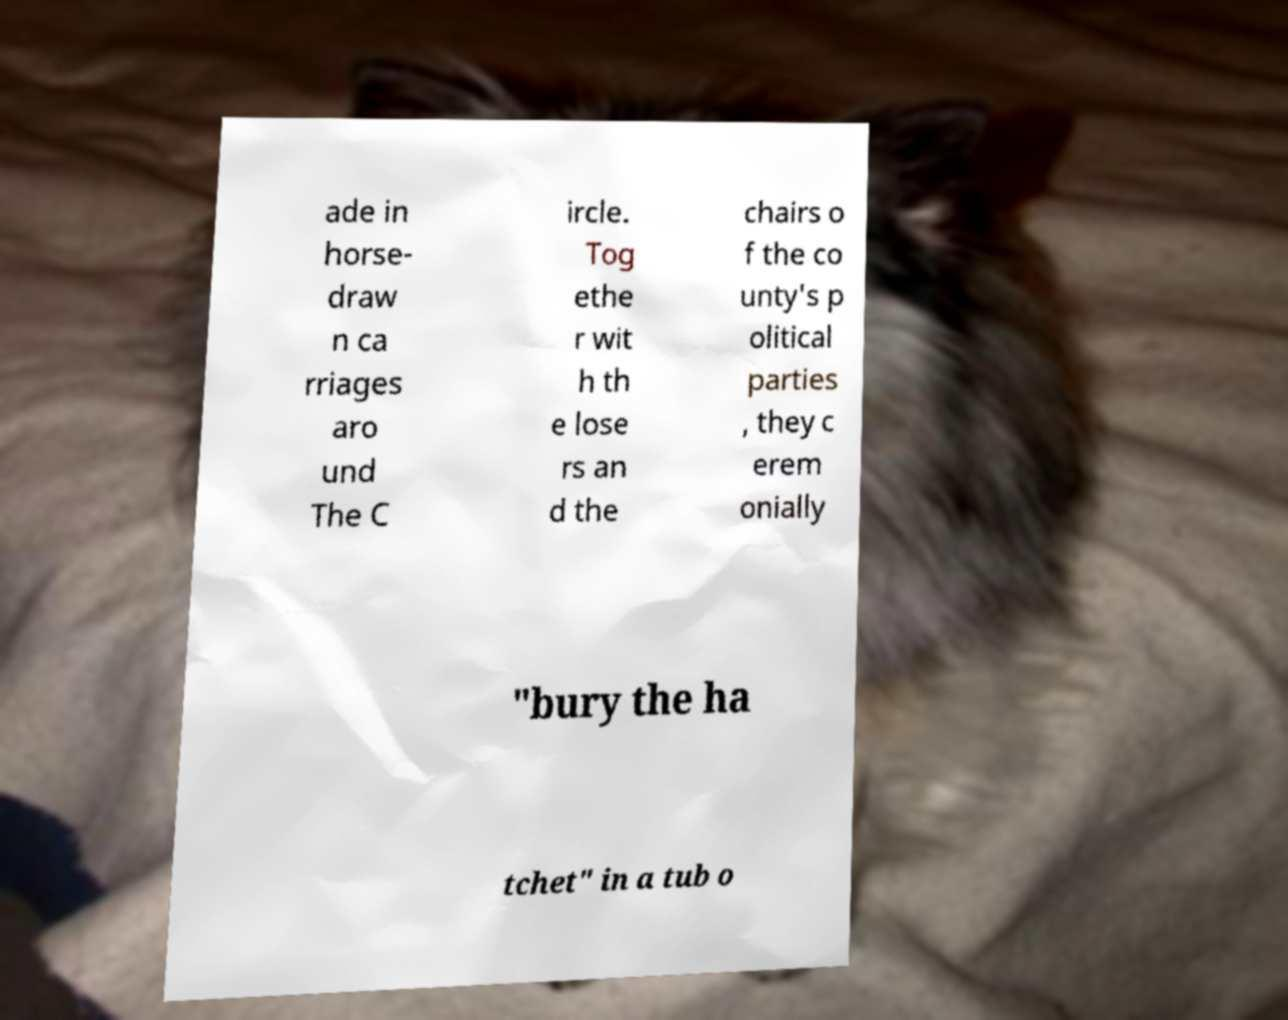I need the written content from this picture converted into text. Can you do that? ade in horse- draw n ca rriages aro und The C ircle. Tog ethe r wit h th e lose rs an d the chairs o f the co unty's p olitical parties , they c erem onially "bury the ha tchet" in a tub o 